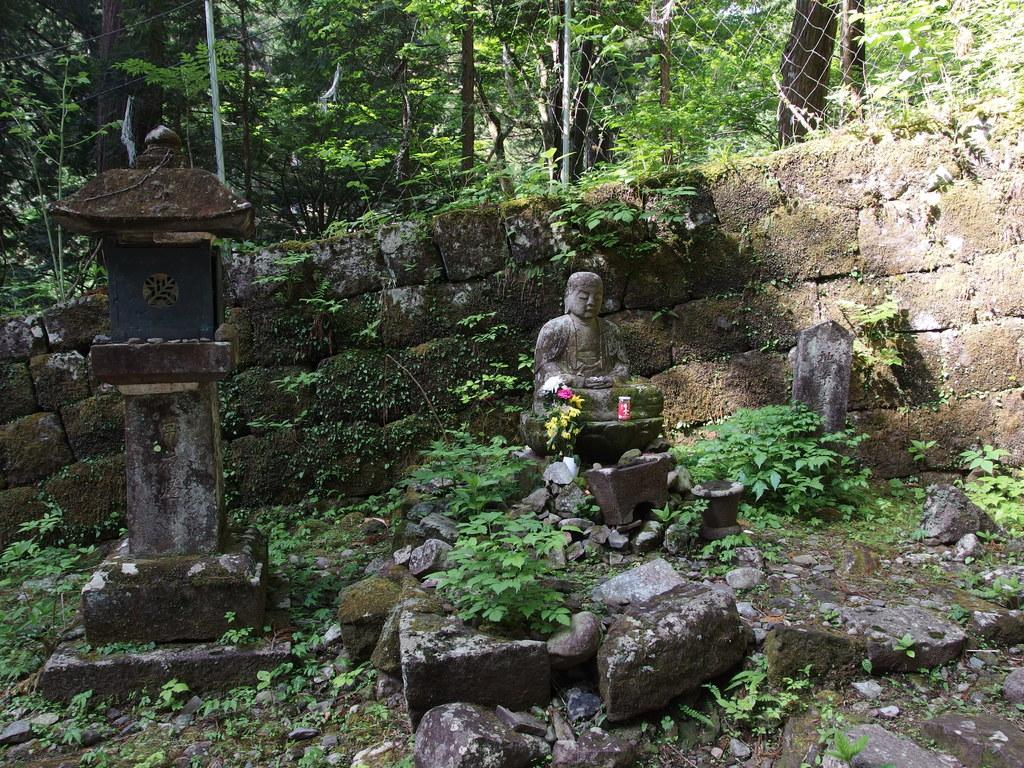What is the main subject of the image? There is an idol in the image. What other elements can be seen in the image? There are rocks, stones, plants, a fence, a wall, and trees in the image. Can you tell me how many buttons are on the idol in the image? There are no buttons present on the idol in the image. What type of order is being followed by the plants in the image? The plants in the image are not following any specific order; they are simply growing in their natural state. 